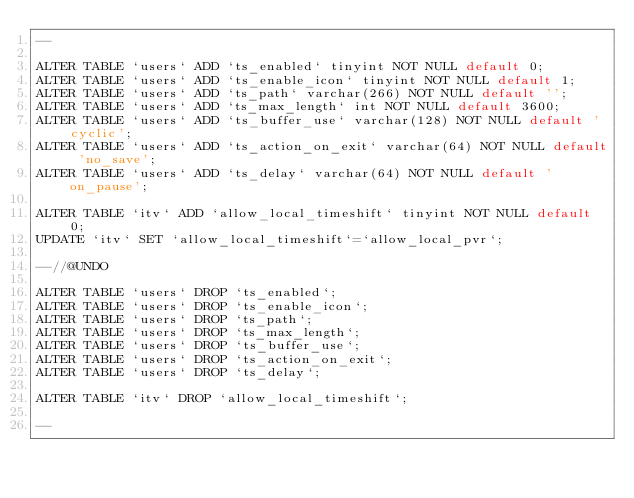Convert code to text. <code><loc_0><loc_0><loc_500><loc_500><_SQL_>--

ALTER TABLE `users` ADD `ts_enabled` tinyint NOT NULL default 0;
ALTER TABLE `users` ADD `ts_enable_icon` tinyint NOT NULL default 1;
ALTER TABLE `users` ADD `ts_path` varchar(266) NOT NULL default '';
ALTER TABLE `users` ADD `ts_max_length` int NOT NULL default 3600;
ALTER TABLE `users` ADD `ts_buffer_use` varchar(128) NOT NULL default 'cyclic';
ALTER TABLE `users` ADD `ts_action_on_exit` varchar(64) NOT NULL default 'no_save';
ALTER TABLE `users` ADD `ts_delay` varchar(64) NOT NULL default 'on_pause';

ALTER TABLE `itv` ADD `allow_local_timeshift` tinyint NOT NULL default 0;
UPDATE `itv` SET `allow_local_timeshift`=`allow_local_pvr`;

--//@UNDO

ALTER TABLE `users` DROP `ts_enabled`;
ALTER TABLE `users` DROP `ts_enable_icon`;
ALTER TABLE `users` DROP `ts_path`;
ALTER TABLE `users` DROP `ts_max_length`;
ALTER TABLE `users` DROP `ts_buffer_use`;
ALTER TABLE `users` DROP `ts_action_on_exit`;
ALTER TABLE `users` DROP `ts_delay`;

ALTER TABLE `itv` DROP `allow_local_timeshift`;

--</code> 